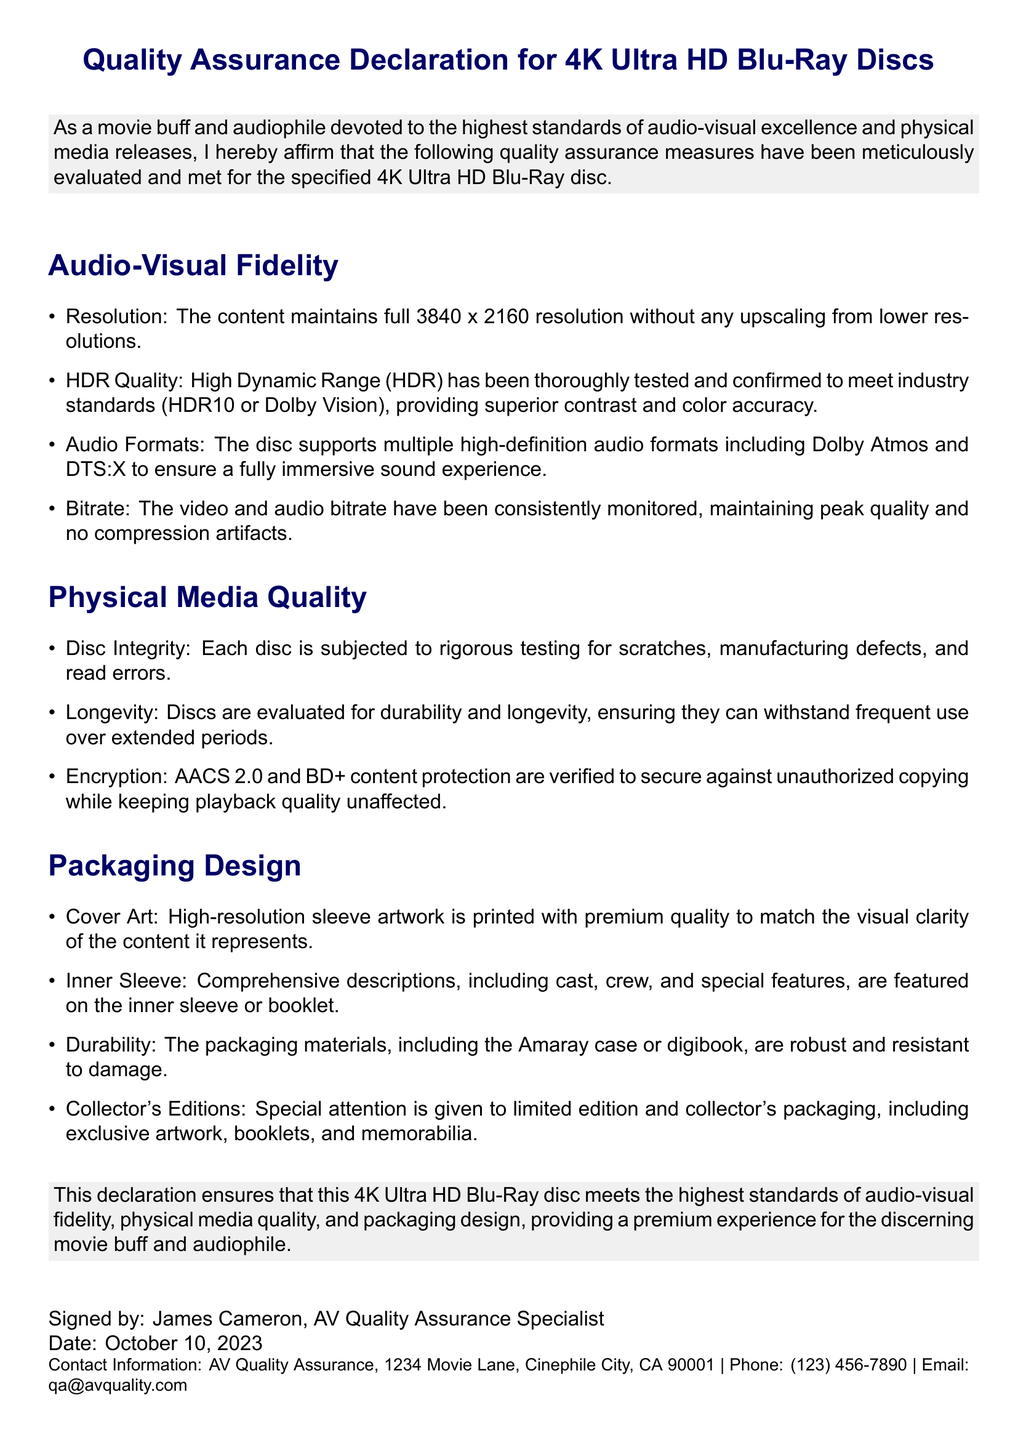what is the resolution of the content? The resolution is stated under Audio-Visual Fidelity as being full 3840 x 2160 resolution.
Answer: 3840 x 2160 what audio formats are mentioned in the document? The document lists multiple high-definition audio formats under Audio-Visual Fidelity.
Answer: Dolby Atmos and DTS:X who signed the declaration? The document states the signatory at the bottom of the declaration.
Answer: James Cameron what date was the declaration signed? The signing date is provided at the bottom of the document.
Answer: October 10, 2023 what type of packaging materials are mentioned? The document refers to the robustness of packaging materials used for the discs, specifically under Packaging Design.
Answer: Amaray case or digibook how is HDR quality confirmed? The HDR quality is mentioned to meet industry standards as described in the Audio-Visual Fidelity section.
Answer: HDR10 or Dolby Vision how are discs evaluated for durability? The document states that discs are subjected to assessments pertaining to durability and longevity under Physical Media Quality.
Answer: Longevity what protection mechanism is used against unauthorized copying? The document lists protection mechanisms related to encryption under Physical Media Quality.
Answer: AACS 2.0 and BD+ 